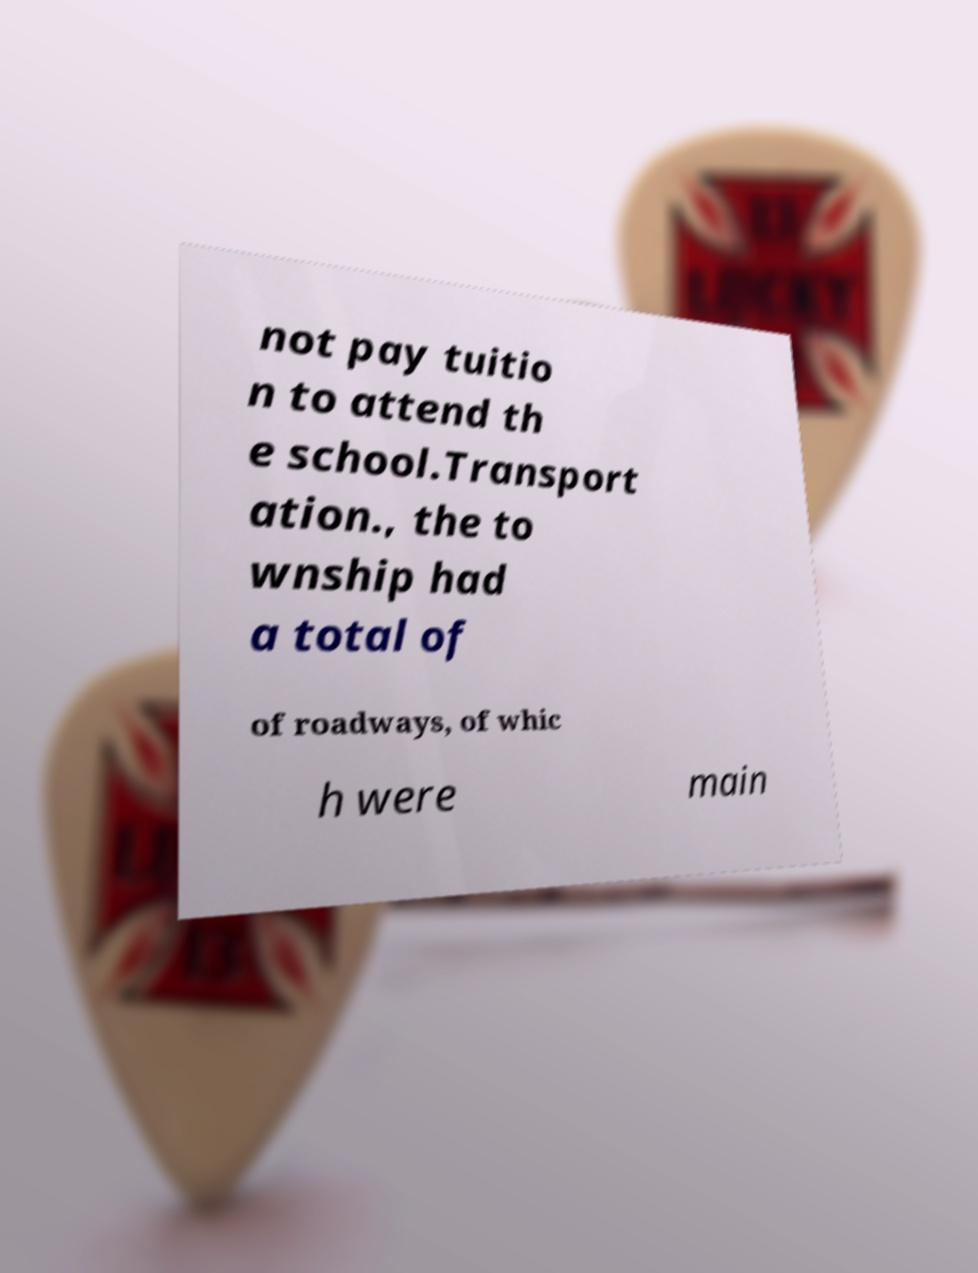Can you read and provide the text displayed in the image?This photo seems to have some interesting text. Can you extract and type it out for me? not pay tuitio n to attend th e school.Transport ation., the to wnship had a total of of roadways, of whic h were main 